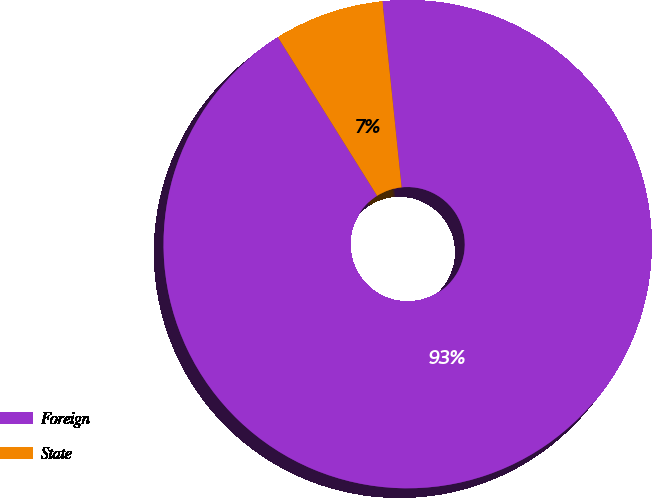Convert chart to OTSL. <chart><loc_0><loc_0><loc_500><loc_500><pie_chart><fcel>Foreign<fcel>State<nl><fcel>92.74%<fcel>7.26%<nl></chart> 